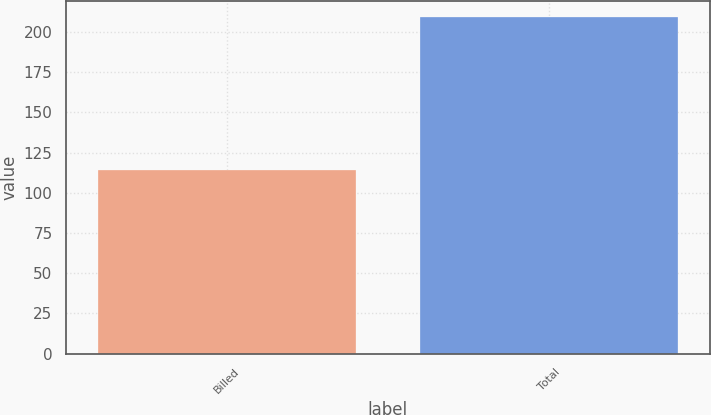Convert chart to OTSL. <chart><loc_0><loc_0><loc_500><loc_500><bar_chart><fcel>Billed<fcel>Total<nl><fcel>114<fcel>209<nl></chart> 